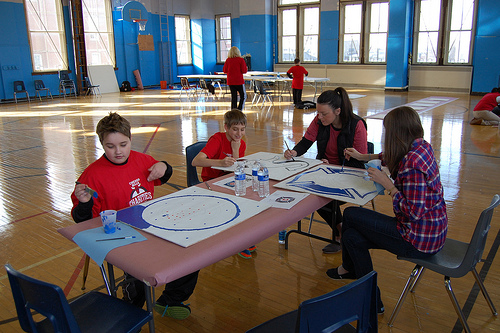<image>
Can you confirm if the boy is to the left of the boy? Yes. From this viewpoint, the boy is positioned to the left side relative to the boy. Where is the painting in relation to the drawing? Is it behind the drawing? No. The painting is not behind the drawing. From this viewpoint, the painting appears to be positioned elsewhere in the scene. 